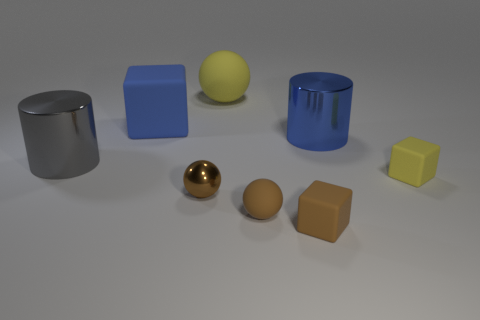What is the color of the object that is on the left side of the large yellow rubber thing and in front of the gray thing?
Your answer should be compact. Brown. Do the shiny ball and the yellow block that is on the right side of the big blue matte block have the same size?
Keep it short and to the point. Yes. Are there any other things that are the same shape as the small brown metal object?
Offer a very short reply. Yes. There is another metallic object that is the same shape as the gray shiny object; what is its color?
Keep it short and to the point. Blue. Do the brown shiny object and the brown block have the same size?
Provide a succinct answer. Yes. What number of things are either big cylinders left of the blue matte cube or cubes behind the brown rubber block?
Offer a terse response. 3. What is the shape of the gray thing that is the same size as the yellow sphere?
Offer a very short reply. Cylinder. There is a blue thing that is the same material as the yellow ball; what is its size?
Your response must be concise. Large. Does the brown metal thing have the same shape as the large gray metal object?
Provide a succinct answer. No. What is the color of the rubber ball that is the same size as the brown metallic sphere?
Provide a short and direct response. Brown. 